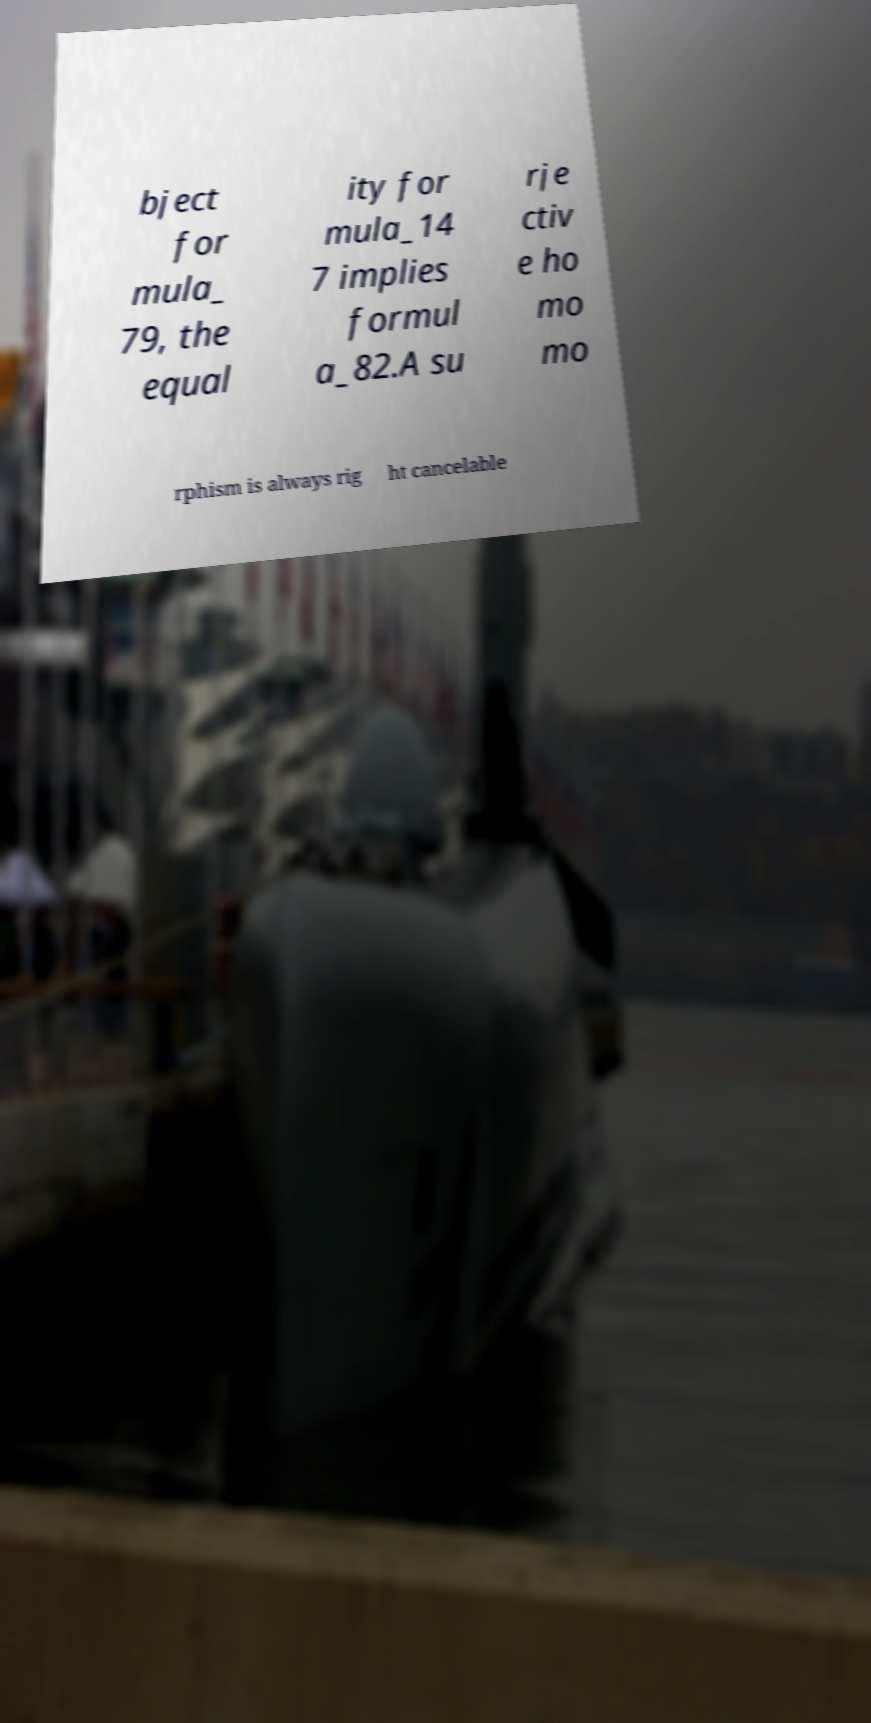What messages or text are displayed in this image? I need them in a readable, typed format. bject for mula_ 79, the equal ity for mula_14 7 implies formul a_82.A su rje ctiv e ho mo mo rphism is always rig ht cancelable 